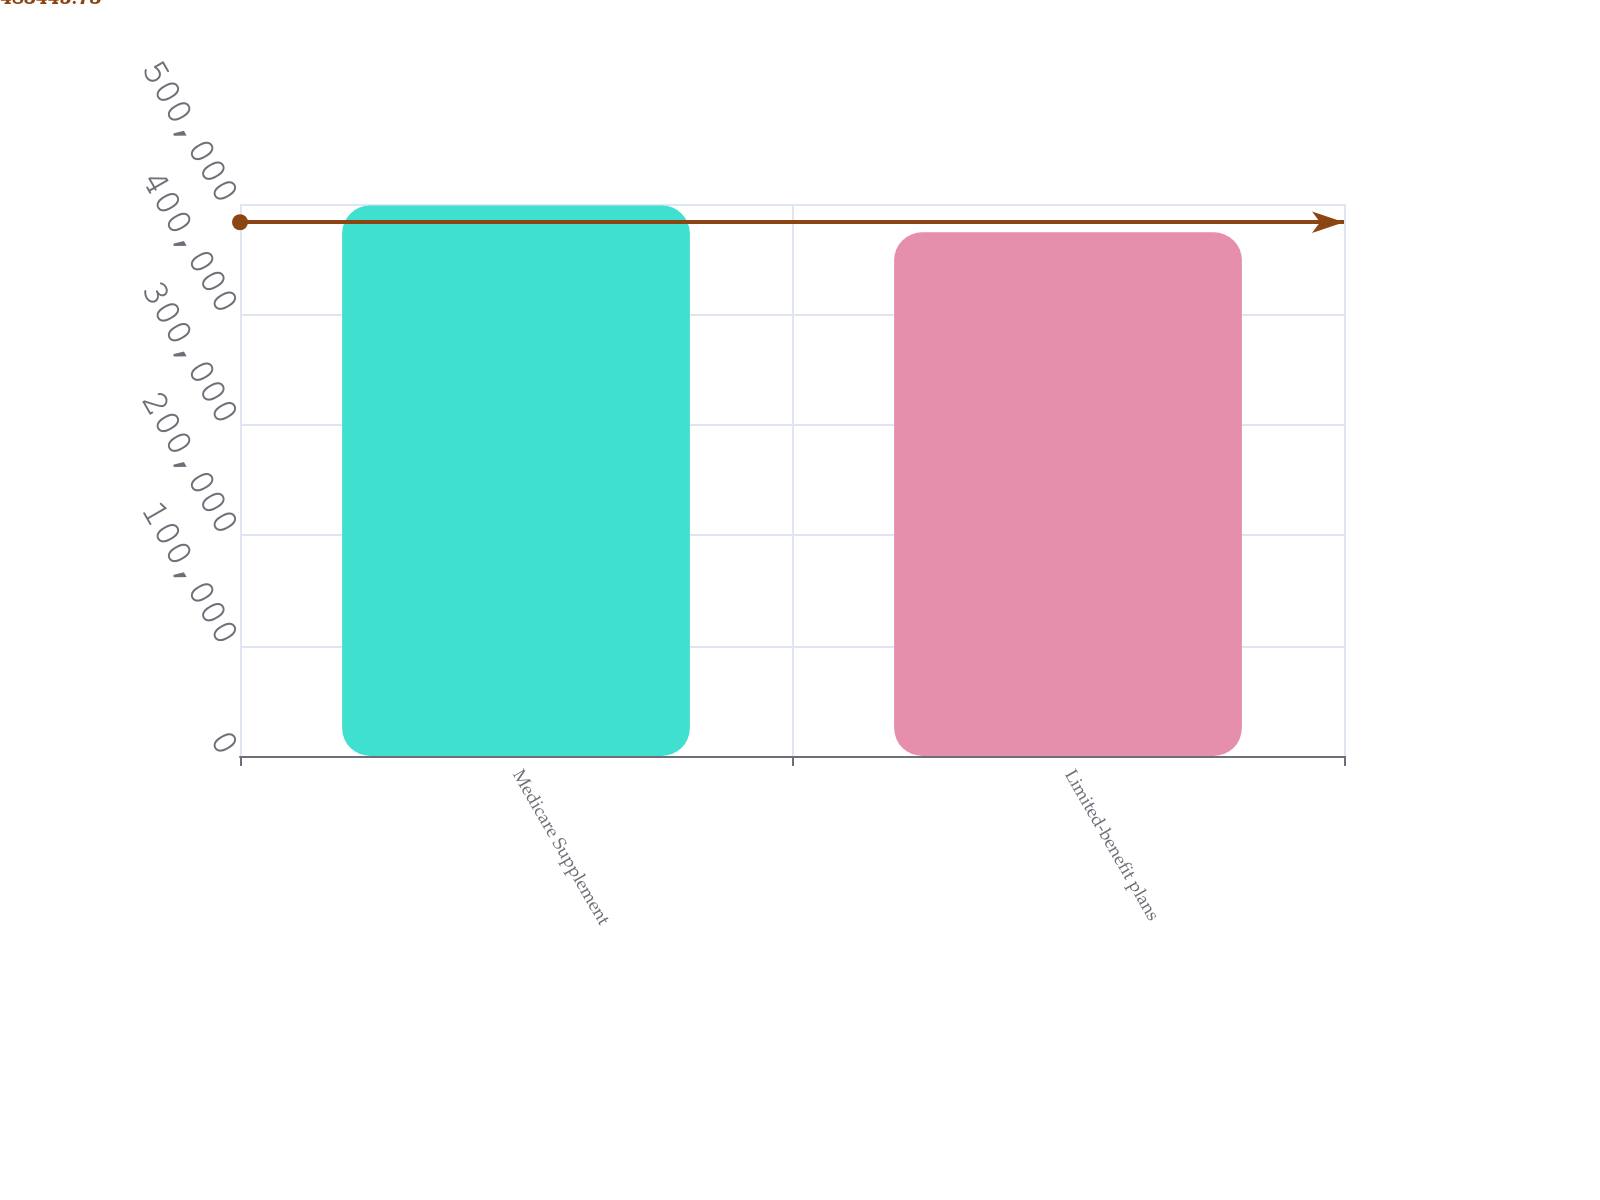<chart> <loc_0><loc_0><loc_500><loc_500><bar_chart><fcel>Medicare Supplement<fcel>Limited-benefit plans<nl><fcel>498696<fcel>474346<nl></chart> 